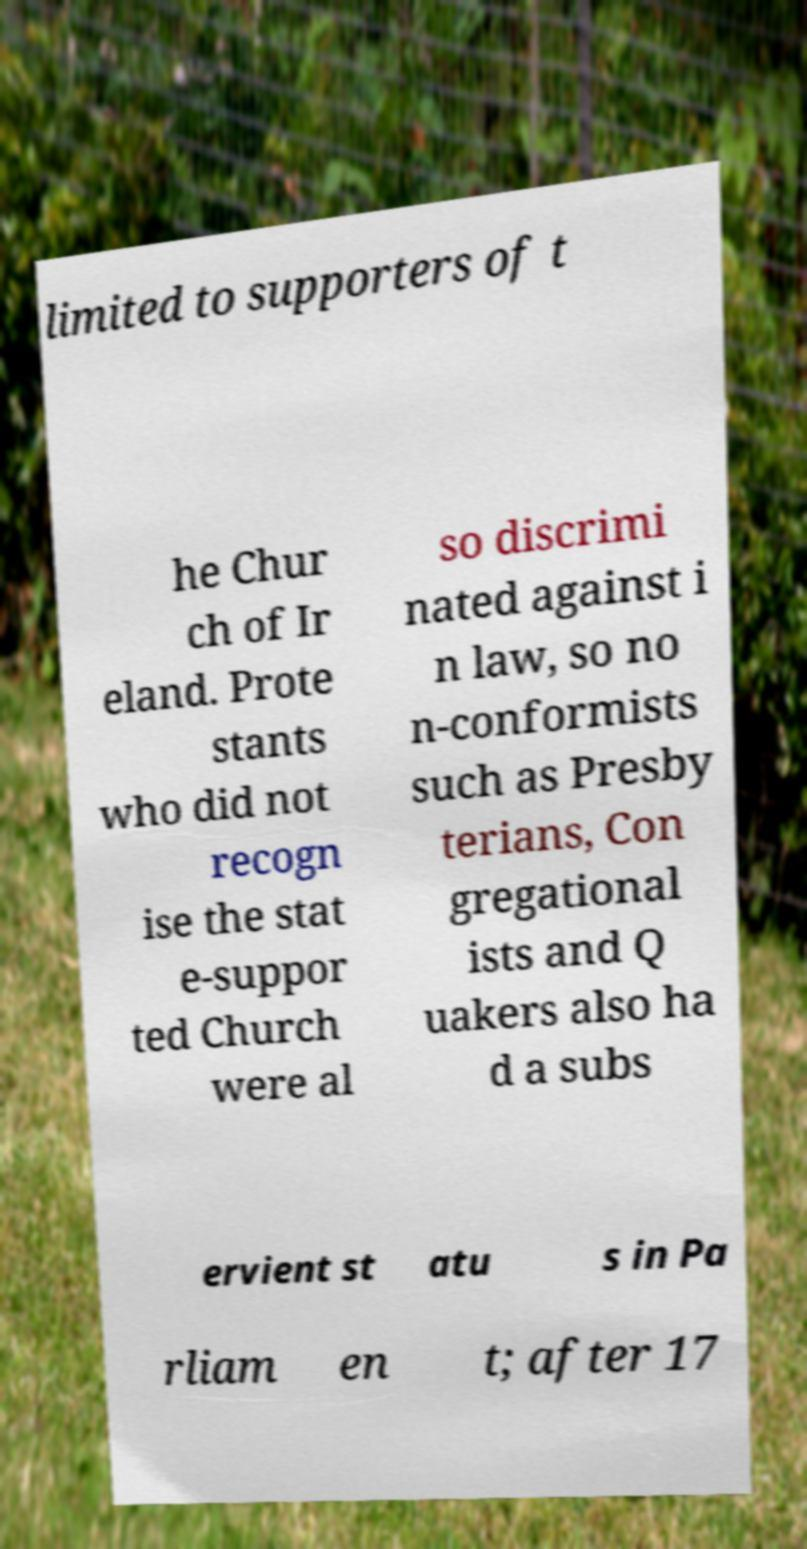Please identify and transcribe the text found in this image. limited to supporters of t he Chur ch of Ir eland. Prote stants who did not recogn ise the stat e-suppor ted Church were al so discrimi nated against i n law, so no n-conformists such as Presby terians, Con gregational ists and Q uakers also ha d a subs ervient st atu s in Pa rliam en t; after 17 